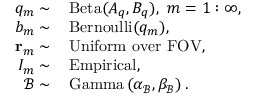<formula> <loc_0><loc_0><loc_500><loc_500>\begin{array} { r l } { q _ { m } \sim } & { \, B e t a ( A _ { q } , B _ { q } ) , \, m = 1 \colon \infty , } \\ { b _ { m } \sim } & { \, B e r n o u l l i ( q _ { m } ) , } \\ { r _ { m } \sim } & { \, U n i f o r m \, o v e r \, F O V , } \\ { I _ { m } \sim } & { \, E m p i r i c a l , } \\ { \mathcal { B } \sim } & { \, G a m m a \left ( \alpha _ { \mathcal { B } } , \beta _ { \mathcal { B } } \right ) . } \end{array}</formula> 